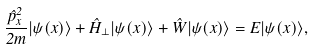Convert formula to latex. <formula><loc_0><loc_0><loc_500><loc_500>\frac { \hat { p } _ { x } ^ { 2 } } { 2 m } | \psi ( x ) \rangle + \hat { H } _ { \perp } | \psi ( x ) \rangle + \hat { W } | \psi ( x ) \rangle = E | \psi ( x ) \rangle ,</formula> 